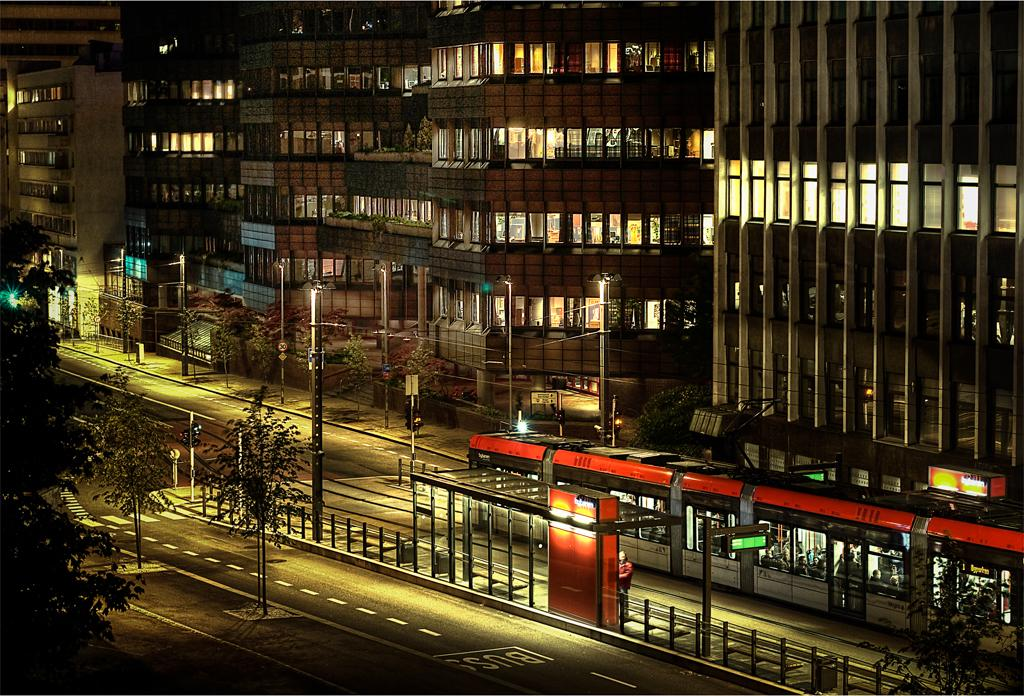What type of structures are visible in the image? There are many buildings in the image. What feature do the buildings have in common? The buildings have windows. What is located at the bottom of the image? There is a road at the bottom of the image. What type of vegetation is on the left side of the image? There are trees on the left side of the image. What mode of transportation can be seen on the right side of the image? There is a train on the right side of the image. What type of brick is used to build the control tower in the image? There is no control tower present in the image, so it is not possible to determine the type of brick used. 